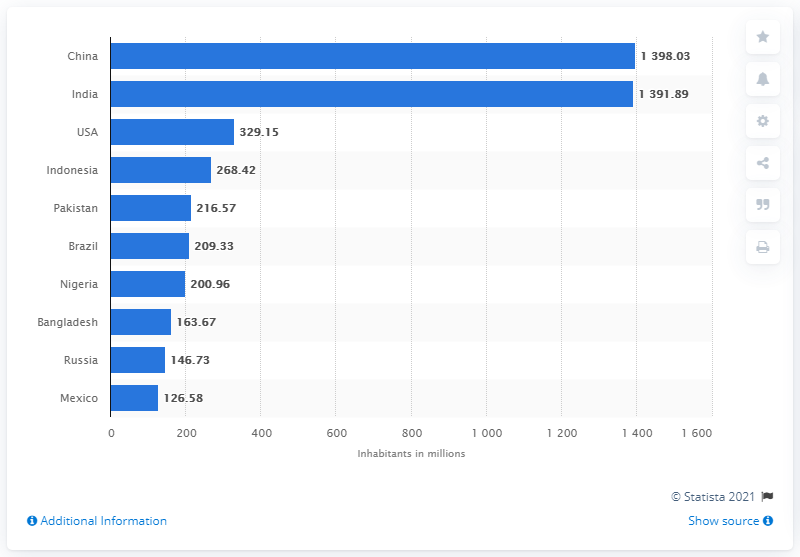Highlight a few significant elements in this photo. As of mid-2019, it is estimated that approximately 1398.03 people lived in China. 